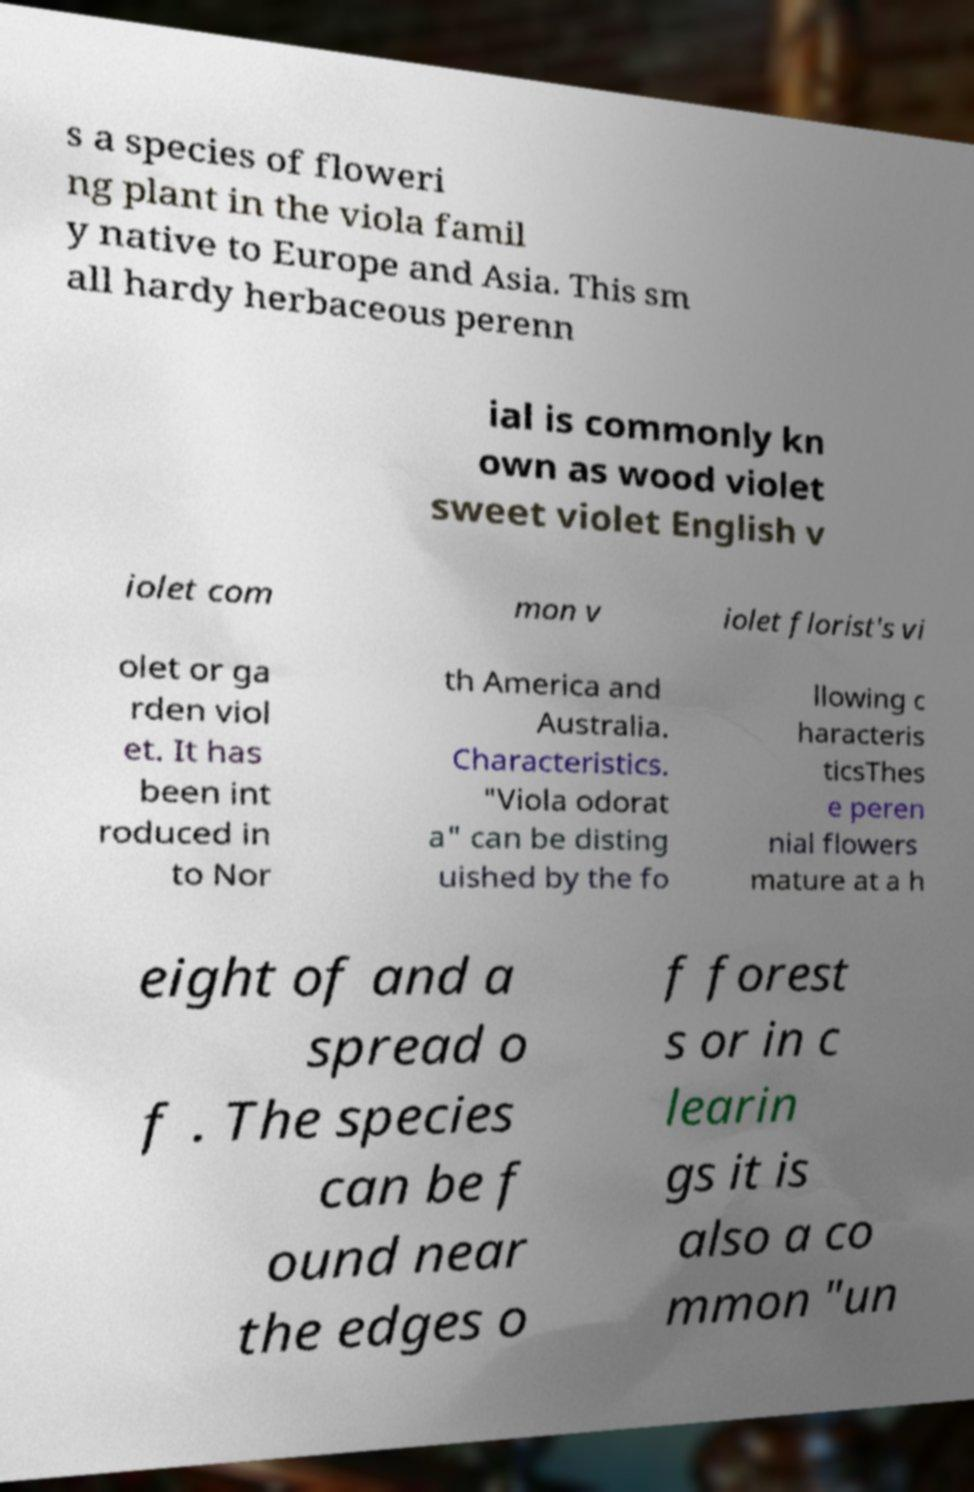There's text embedded in this image that I need extracted. Can you transcribe it verbatim? s a species of floweri ng plant in the viola famil y native to Europe and Asia. This sm all hardy herbaceous perenn ial is commonly kn own as wood violet sweet violet English v iolet com mon v iolet florist's vi olet or ga rden viol et. It has been int roduced in to Nor th America and Australia. Characteristics. "Viola odorat a" can be disting uished by the fo llowing c haracteris ticsThes e peren nial flowers mature at a h eight of and a spread o f . The species can be f ound near the edges o f forest s or in c learin gs it is also a co mmon "un 